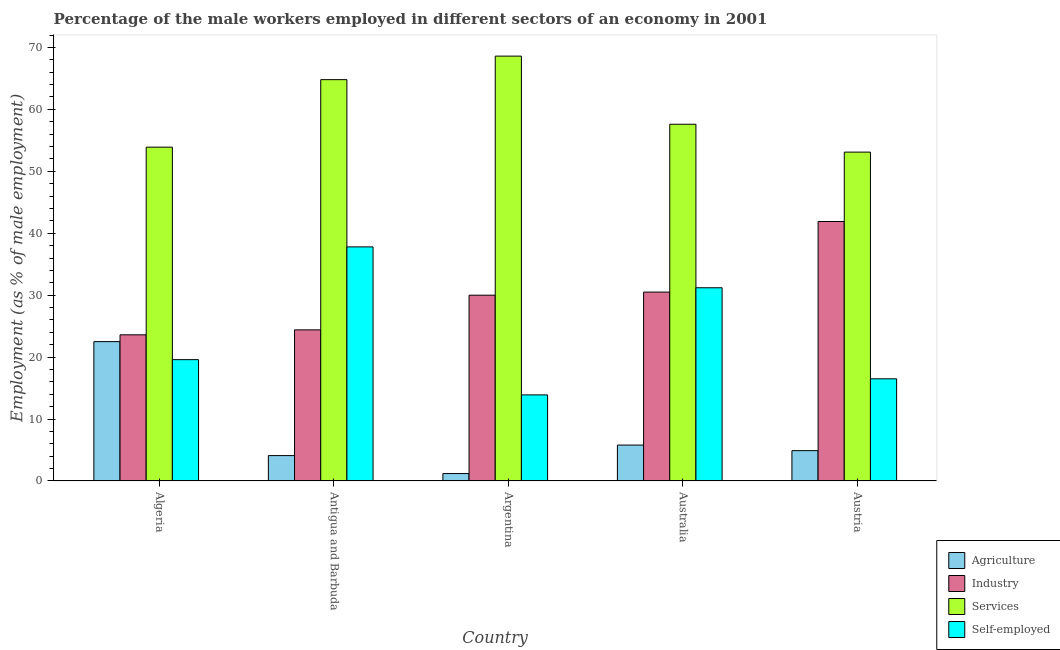How many different coloured bars are there?
Provide a short and direct response. 4. Are the number of bars per tick equal to the number of legend labels?
Provide a short and direct response. Yes. Are the number of bars on each tick of the X-axis equal?
Offer a very short reply. Yes. What is the label of the 2nd group of bars from the left?
Ensure brevity in your answer.  Antigua and Barbuda. What is the percentage of male workers in industry in Algeria?
Give a very brief answer. 23.6. Across all countries, what is the maximum percentage of male workers in industry?
Your answer should be compact. 41.9. Across all countries, what is the minimum percentage of self employed male workers?
Provide a succinct answer. 13.9. In which country was the percentage of self employed male workers maximum?
Give a very brief answer. Antigua and Barbuda. What is the total percentage of male workers in services in the graph?
Offer a terse response. 298. What is the difference between the percentage of male workers in industry in Australia and that in Austria?
Provide a succinct answer. -11.4. What is the difference between the percentage of self employed male workers in Australia and the percentage of male workers in industry in Algeria?
Keep it short and to the point. 7.6. What is the average percentage of male workers in services per country?
Ensure brevity in your answer.  59.6. What is the difference between the percentage of self employed male workers and percentage of male workers in agriculture in Australia?
Offer a terse response. 25.4. What is the ratio of the percentage of male workers in services in Algeria to that in Antigua and Barbuda?
Ensure brevity in your answer.  0.83. Is the difference between the percentage of male workers in industry in Algeria and Austria greater than the difference between the percentage of self employed male workers in Algeria and Austria?
Offer a very short reply. No. What is the difference between the highest and the second highest percentage of male workers in agriculture?
Provide a succinct answer. 16.7. What is the difference between the highest and the lowest percentage of self employed male workers?
Your answer should be very brief. 23.9. In how many countries, is the percentage of self employed male workers greater than the average percentage of self employed male workers taken over all countries?
Your response must be concise. 2. Is the sum of the percentage of male workers in services in Antigua and Barbuda and Australia greater than the maximum percentage of male workers in industry across all countries?
Your response must be concise. Yes. Is it the case that in every country, the sum of the percentage of male workers in services and percentage of male workers in agriculture is greater than the sum of percentage of self employed male workers and percentage of male workers in industry?
Ensure brevity in your answer.  Yes. What does the 1st bar from the left in Antigua and Barbuda represents?
Offer a very short reply. Agriculture. What does the 3rd bar from the right in Antigua and Barbuda represents?
Your answer should be compact. Industry. Are all the bars in the graph horizontal?
Ensure brevity in your answer.  No. What is the difference between two consecutive major ticks on the Y-axis?
Your answer should be very brief. 10. Does the graph contain any zero values?
Give a very brief answer. No. Does the graph contain grids?
Provide a short and direct response. No. Where does the legend appear in the graph?
Keep it short and to the point. Bottom right. How many legend labels are there?
Your response must be concise. 4. What is the title of the graph?
Your answer should be very brief. Percentage of the male workers employed in different sectors of an economy in 2001. What is the label or title of the X-axis?
Ensure brevity in your answer.  Country. What is the label or title of the Y-axis?
Provide a succinct answer. Employment (as % of male employment). What is the Employment (as % of male employment) of Industry in Algeria?
Provide a succinct answer. 23.6. What is the Employment (as % of male employment) in Services in Algeria?
Your response must be concise. 53.9. What is the Employment (as % of male employment) in Self-employed in Algeria?
Make the answer very short. 19.59. What is the Employment (as % of male employment) of Agriculture in Antigua and Barbuda?
Keep it short and to the point. 4.1. What is the Employment (as % of male employment) of Industry in Antigua and Barbuda?
Your answer should be very brief. 24.4. What is the Employment (as % of male employment) of Services in Antigua and Barbuda?
Offer a terse response. 64.8. What is the Employment (as % of male employment) of Self-employed in Antigua and Barbuda?
Give a very brief answer. 37.8. What is the Employment (as % of male employment) of Agriculture in Argentina?
Give a very brief answer. 1.2. What is the Employment (as % of male employment) in Industry in Argentina?
Your answer should be compact. 30. What is the Employment (as % of male employment) of Services in Argentina?
Your response must be concise. 68.6. What is the Employment (as % of male employment) of Self-employed in Argentina?
Ensure brevity in your answer.  13.9. What is the Employment (as % of male employment) in Agriculture in Australia?
Offer a terse response. 5.8. What is the Employment (as % of male employment) in Industry in Australia?
Offer a terse response. 30.5. What is the Employment (as % of male employment) of Services in Australia?
Your response must be concise. 57.6. What is the Employment (as % of male employment) of Self-employed in Australia?
Give a very brief answer. 31.2. What is the Employment (as % of male employment) in Agriculture in Austria?
Give a very brief answer. 4.9. What is the Employment (as % of male employment) in Industry in Austria?
Make the answer very short. 41.9. What is the Employment (as % of male employment) of Services in Austria?
Provide a succinct answer. 53.1. What is the Employment (as % of male employment) in Self-employed in Austria?
Offer a terse response. 16.5. Across all countries, what is the maximum Employment (as % of male employment) in Agriculture?
Provide a short and direct response. 22.5. Across all countries, what is the maximum Employment (as % of male employment) of Industry?
Your answer should be very brief. 41.9. Across all countries, what is the maximum Employment (as % of male employment) of Services?
Offer a terse response. 68.6. Across all countries, what is the maximum Employment (as % of male employment) in Self-employed?
Give a very brief answer. 37.8. Across all countries, what is the minimum Employment (as % of male employment) in Agriculture?
Offer a terse response. 1.2. Across all countries, what is the minimum Employment (as % of male employment) in Industry?
Give a very brief answer. 23.6. Across all countries, what is the minimum Employment (as % of male employment) of Services?
Your response must be concise. 53.1. Across all countries, what is the minimum Employment (as % of male employment) in Self-employed?
Your answer should be compact. 13.9. What is the total Employment (as % of male employment) of Agriculture in the graph?
Provide a short and direct response. 38.5. What is the total Employment (as % of male employment) in Industry in the graph?
Make the answer very short. 150.4. What is the total Employment (as % of male employment) of Services in the graph?
Your response must be concise. 298. What is the total Employment (as % of male employment) of Self-employed in the graph?
Your response must be concise. 118.99. What is the difference between the Employment (as % of male employment) in Agriculture in Algeria and that in Antigua and Barbuda?
Make the answer very short. 18.4. What is the difference between the Employment (as % of male employment) of Self-employed in Algeria and that in Antigua and Barbuda?
Keep it short and to the point. -18.21. What is the difference between the Employment (as % of male employment) in Agriculture in Algeria and that in Argentina?
Give a very brief answer. 21.3. What is the difference between the Employment (as % of male employment) in Industry in Algeria and that in Argentina?
Your response must be concise. -6.4. What is the difference between the Employment (as % of male employment) of Services in Algeria and that in Argentina?
Provide a short and direct response. -14.7. What is the difference between the Employment (as % of male employment) of Self-employed in Algeria and that in Argentina?
Offer a terse response. 5.69. What is the difference between the Employment (as % of male employment) in Self-employed in Algeria and that in Australia?
Provide a succinct answer. -11.61. What is the difference between the Employment (as % of male employment) in Industry in Algeria and that in Austria?
Keep it short and to the point. -18.3. What is the difference between the Employment (as % of male employment) of Self-employed in Algeria and that in Austria?
Provide a succinct answer. 3.09. What is the difference between the Employment (as % of male employment) of Self-employed in Antigua and Barbuda and that in Argentina?
Offer a very short reply. 23.9. What is the difference between the Employment (as % of male employment) of Self-employed in Antigua and Barbuda and that in Australia?
Your answer should be very brief. 6.6. What is the difference between the Employment (as % of male employment) in Industry in Antigua and Barbuda and that in Austria?
Provide a short and direct response. -17.5. What is the difference between the Employment (as % of male employment) of Services in Antigua and Barbuda and that in Austria?
Your response must be concise. 11.7. What is the difference between the Employment (as % of male employment) in Self-employed in Antigua and Barbuda and that in Austria?
Keep it short and to the point. 21.3. What is the difference between the Employment (as % of male employment) in Agriculture in Argentina and that in Australia?
Provide a short and direct response. -4.6. What is the difference between the Employment (as % of male employment) in Services in Argentina and that in Australia?
Ensure brevity in your answer.  11. What is the difference between the Employment (as % of male employment) in Self-employed in Argentina and that in Australia?
Your response must be concise. -17.3. What is the difference between the Employment (as % of male employment) of Services in Argentina and that in Austria?
Give a very brief answer. 15.5. What is the difference between the Employment (as % of male employment) in Self-employed in Argentina and that in Austria?
Provide a short and direct response. -2.6. What is the difference between the Employment (as % of male employment) in Agriculture in Australia and that in Austria?
Provide a short and direct response. 0.9. What is the difference between the Employment (as % of male employment) in Industry in Australia and that in Austria?
Give a very brief answer. -11.4. What is the difference between the Employment (as % of male employment) in Services in Australia and that in Austria?
Offer a very short reply. 4.5. What is the difference between the Employment (as % of male employment) of Self-employed in Australia and that in Austria?
Offer a terse response. 14.7. What is the difference between the Employment (as % of male employment) in Agriculture in Algeria and the Employment (as % of male employment) in Industry in Antigua and Barbuda?
Your answer should be very brief. -1.9. What is the difference between the Employment (as % of male employment) in Agriculture in Algeria and the Employment (as % of male employment) in Services in Antigua and Barbuda?
Offer a very short reply. -42.3. What is the difference between the Employment (as % of male employment) in Agriculture in Algeria and the Employment (as % of male employment) in Self-employed in Antigua and Barbuda?
Provide a short and direct response. -15.3. What is the difference between the Employment (as % of male employment) in Industry in Algeria and the Employment (as % of male employment) in Services in Antigua and Barbuda?
Offer a terse response. -41.2. What is the difference between the Employment (as % of male employment) of Services in Algeria and the Employment (as % of male employment) of Self-employed in Antigua and Barbuda?
Keep it short and to the point. 16.1. What is the difference between the Employment (as % of male employment) of Agriculture in Algeria and the Employment (as % of male employment) of Industry in Argentina?
Your response must be concise. -7.5. What is the difference between the Employment (as % of male employment) of Agriculture in Algeria and the Employment (as % of male employment) of Services in Argentina?
Make the answer very short. -46.1. What is the difference between the Employment (as % of male employment) of Industry in Algeria and the Employment (as % of male employment) of Services in Argentina?
Ensure brevity in your answer.  -45. What is the difference between the Employment (as % of male employment) of Agriculture in Algeria and the Employment (as % of male employment) of Industry in Australia?
Keep it short and to the point. -8. What is the difference between the Employment (as % of male employment) in Agriculture in Algeria and the Employment (as % of male employment) in Services in Australia?
Your answer should be compact. -35.1. What is the difference between the Employment (as % of male employment) of Industry in Algeria and the Employment (as % of male employment) of Services in Australia?
Offer a terse response. -34. What is the difference between the Employment (as % of male employment) of Industry in Algeria and the Employment (as % of male employment) of Self-employed in Australia?
Your response must be concise. -7.6. What is the difference between the Employment (as % of male employment) in Services in Algeria and the Employment (as % of male employment) in Self-employed in Australia?
Your response must be concise. 22.7. What is the difference between the Employment (as % of male employment) in Agriculture in Algeria and the Employment (as % of male employment) in Industry in Austria?
Your answer should be very brief. -19.4. What is the difference between the Employment (as % of male employment) in Agriculture in Algeria and the Employment (as % of male employment) in Services in Austria?
Offer a terse response. -30.6. What is the difference between the Employment (as % of male employment) of Industry in Algeria and the Employment (as % of male employment) of Services in Austria?
Provide a succinct answer. -29.5. What is the difference between the Employment (as % of male employment) in Services in Algeria and the Employment (as % of male employment) in Self-employed in Austria?
Offer a terse response. 37.4. What is the difference between the Employment (as % of male employment) in Agriculture in Antigua and Barbuda and the Employment (as % of male employment) in Industry in Argentina?
Ensure brevity in your answer.  -25.9. What is the difference between the Employment (as % of male employment) in Agriculture in Antigua and Barbuda and the Employment (as % of male employment) in Services in Argentina?
Your answer should be compact. -64.5. What is the difference between the Employment (as % of male employment) of Agriculture in Antigua and Barbuda and the Employment (as % of male employment) of Self-employed in Argentina?
Ensure brevity in your answer.  -9.8. What is the difference between the Employment (as % of male employment) in Industry in Antigua and Barbuda and the Employment (as % of male employment) in Services in Argentina?
Provide a succinct answer. -44.2. What is the difference between the Employment (as % of male employment) of Services in Antigua and Barbuda and the Employment (as % of male employment) of Self-employed in Argentina?
Ensure brevity in your answer.  50.9. What is the difference between the Employment (as % of male employment) in Agriculture in Antigua and Barbuda and the Employment (as % of male employment) in Industry in Australia?
Keep it short and to the point. -26.4. What is the difference between the Employment (as % of male employment) of Agriculture in Antigua and Barbuda and the Employment (as % of male employment) of Services in Australia?
Provide a succinct answer. -53.5. What is the difference between the Employment (as % of male employment) in Agriculture in Antigua and Barbuda and the Employment (as % of male employment) in Self-employed in Australia?
Give a very brief answer. -27.1. What is the difference between the Employment (as % of male employment) of Industry in Antigua and Barbuda and the Employment (as % of male employment) of Services in Australia?
Give a very brief answer. -33.2. What is the difference between the Employment (as % of male employment) of Services in Antigua and Barbuda and the Employment (as % of male employment) of Self-employed in Australia?
Ensure brevity in your answer.  33.6. What is the difference between the Employment (as % of male employment) in Agriculture in Antigua and Barbuda and the Employment (as % of male employment) in Industry in Austria?
Provide a succinct answer. -37.8. What is the difference between the Employment (as % of male employment) of Agriculture in Antigua and Barbuda and the Employment (as % of male employment) of Services in Austria?
Offer a terse response. -49. What is the difference between the Employment (as % of male employment) in Agriculture in Antigua and Barbuda and the Employment (as % of male employment) in Self-employed in Austria?
Offer a terse response. -12.4. What is the difference between the Employment (as % of male employment) of Industry in Antigua and Barbuda and the Employment (as % of male employment) of Services in Austria?
Your answer should be very brief. -28.7. What is the difference between the Employment (as % of male employment) in Services in Antigua and Barbuda and the Employment (as % of male employment) in Self-employed in Austria?
Ensure brevity in your answer.  48.3. What is the difference between the Employment (as % of male employment) in Agriculture in Argentina and the Employment (as % of male employment) in Industry in Australia?
Keep it short and to the point. -29.3. What is the difference between the Employment (as % of male employment) in Agriculture in Argentina and the Employment (as % of male employment) in Services in Australia?
Provide a succinct answer. -56.4. What is the difference between the Employment (as % of male employment) of Industry in Argentina and the Employment (as % of male employment) of Services in Australia?
Make the answer very short. -27.6. What is the difference between the Employment (as % of male employment) in Industry in Argentina and the Employment (as % of male employment) in Self-employed in Australia?
Offer a very short reply. -1.2. What is the difference between the Employment (as % of male employment) of Services in Argentina and the Employment (as % of male employment) of Self-employed in Australia?
Offer a very short reply. 37.4. What is the difference between the Employment (as % of male employment) in Agriculture in Argentina and the Employment (as % of male employment) in Industry in Austria?
Your response must be concise. -40.7. What is the difference between the Employment (as % of male employment) in Agriculture in Argentina and the Employment (as % of male employment) in Services in Austria?
Make the answer very short. -51.9. What is the difference between the Employment (as % of male employment) in Agriculture in Argentina and the Employment (as % of male employment) in Self-employed in Austria?
Make the answer very short. -15.3. What is the difference between the Employment (as % of male employment) of Industry in Argentina and the Employment (as % of male employment) of Services in Austria?
Make the answer very short. -23.1. What is the difference between the Employment (as % of male employment) in Services in Argentina and the Employment (as % of male employment) in Self-employed in Austria?
Offer a terse response. 52.1. What is the difference between the Employment (as % of male employment) of Agriculture in Australia and the Employment (as % of male employment) of Industry in Austria?
Your response must be concise. -36.1. What is the difference between the Employment (as % of male employment) in Agriculture in Australia and the Employment (as % of male employment) in Services in Austria?
Your answer should be compact. -47.3. What is the difference between the Employment (as % of male employment) in Agriculture in Australia and the Employment (as % of male employment) in Self-employed in Austria?
Your response must be concise. -10.7. What is the difference between the Employment (as % of male employment) of Industry in Australia and the Employment (as % of male employment) of Services in Austria?
Ensure brevity in your answer.  -22.6. What is the difference between the Employment (as % of male employment) of Services in Australia and the Employment (as % of male employment) of Self-employed in Austria?
Keep it short and to the point. 41.1. What is the average Employment (as % of male employment) in Agriculture per country?
Offer a very short reply. 7.7. What is the average Employment (as % of male employment) in Industry per country?
Provide a succinct answer. 30.08. What is the average Employment (as % of male employment) of Services per country?
Offer a terse response. 59.6. What is the average Employment (as % of male employment) in Self-employed per country?
Your answer should be compact. 23.8. What is the difference between the Employment (as % of male employment) in Agriculture and Employment (as % of male employment) in Services in Algeria?
Your answer should be compact. -31.4. What is the difference between the Employment (as % of male employment) in Agriculture and Employment (as % of male employment) in Self-employed in Algeria?
Offer a very short reply. 2.91. What is the difference between the Employment (as % of male employment) in Industry and Employment (as % of male employment) in Services in Algeria?
Offer a terse response. -30.3. What is the difference between the Employment (as % of male employment) of Industry and Employment (as % of male employment) of Self-employed in Algeria?
Give a very brief answer. 4.01. What is the difference between the Employment (as % of male employment) of Services and Employment (as % of male employment) of Self-employed in Algeria?
Offer a very short reply. 34.31. What is the difference between the Employment (as % of male employment) in Agriculture and Employment (as % of male employment) in Industry in Antigua and Barbuda?
Make the answer very short. -20.3. What is the difference between the Employment (as % of male employment) in Agriculture and Employment (as % of male employment) in Services in Antigua and Barbuda?
Offer a very short reply. -60.7. What is the difference between the Employment (as % of male employment) in Agriculture and Employment (as % of male employment) in Self-employed in Antigua and Barbuda?
Offer a very short reply. -33.7. What is the difference between the Employment (as % of male employment) of Industry and Employment (as % of male employment) of Services in Antigua and Barbuda?
Offer a terse response. -40.4. What is the difference between the Employment (as % of male employment) of Agriculture and Employment (as % of male employment) of Industry in Argentina?
Provide a short and direct response. -28.8. What is the difference between the Employment (as % of male employment) in Agriculture and Employment (as % of male employment) in Services in Argentina?
Provide a succinct answer. -67.4. What is the difference between the Employment (as % of male employment) in Industry and Employment (as % of male employment) in Services in Argentina?
Keep it short and to the point. -38.6. What is the difference between the Employment (as % of male employment) of Services and Employment (as % of male employment) of Self-employed in Argentina?
Your response must be concise. 54.7. What is the difference between the Employment (as % of male employment) of Agriculture and Employment (as % of male employment) of Industry in Australia?
Make the answer very short. -24.7. What is the difference between the Employment (as % of male employment) in Agriculture and Employment (as % of male employment) in Services in Australia?
Provide a short and direct response. -51.8. What is the difference between the Employment (as % of male employment) of Agriculture and Employment (as % of male employment) of Self-employed in Australia?
Your response must be concise. -25.4. What is the difference between the Employment (as % of male employment) in Industry and Employment (as % of male employment) in Services in Australia?
Your answer should be very brief. -27.1. What is the difference between the Employment (as % of male employment) in Services and Employment (as % of male employment) in Self-employed in Australia?
Give a very brief answer. 26.4. What is the difference between the Employment (as % of male employment) in Agriculture and Employment (as % of male employment) in Industry in Austria?
Give a very brief answer. -37. What is the difference between the Employment (as % of male employment) in Agriculture and Employment (as % of male employment) in Services in Austria?
Ensure brevity in your answer.  -48.2. What is the difference between the Employment (as % of male employment) in Industry and Employment (as % of male employment) in Services in Austria?
Keep it short and to the point. -11.2. What is the difference between the Employment (as % of male employment) of Industry and Employment (as % of male employment) of Self-employed in Austria?
Ensure brevity in your answer.  25.4. What is the difference between the Employment (as % of male employment) in Services and Employment (as % of male employment) in Self-employed in Austria?
Make the answer very short. 36.6. What is the ratio of the Employment (as % of male employment) in Agriculture in Algeria to that in Antigua and Barbuda?
Keep it short and to the point. 5.49. What is the ratio of the Employment (as % of male employment) in Industry in Algeria to that in Antigua and Barbuda?
Give a very brief answer. 0.97. What is the ratio of the Employment (as % of male employment) of Services in Algeria to that in Antigua and Barbuda?
Provide a short and direct response. 0.83. What is the ratio of the Employment (as % of male employment) in Self-employed in Algeria to that in Antigua and Barbuda?
Your answer should be compact. 0.52. What is the ratio of the Employment (as % of male employment) in Agriculture in Algeria to that in Argentina?
Ensure brevity in your answer.  18.75. What is the ratio of the Employment (as % of male employment) in Industry in Algeria to that in Argentina?
Your answer should be compact. 0.79. What is the ratio of the Employment (as % of male employment) of Services in Algeria to that in Argentina?
Make the answer very short. 0.79. What is the ratio of the Employment (as % of male employment) in Self-employed in Algeria to that in Argentina?
Your answer should be very brief. 1.41. What is the ratio of the Employment (as % of male employment) of Agriculture in Algeria to that in Australia?
Provide a short and direct response. 3.88. What is the ratio of the Employment (as % of male employment) of Industry in Algeria to that in Australia?
Offer a terse response. 0.77. What is the ratio of the Employment (as % of male employment) in Services in Algeria to that in Australia?
Offer a terse response. 0.94. What is the ratio of the Employment (as % of male employment) of Self-employed in Algeria to that in Australia?
Your answer should be compact. 0.63. What is the ratio of the Employment (as % of male employment) of Agriculture in Algeria to that in Austria?
Give a very brief answer. 4.59. What is the ratio of the Employment (as % of male employment) of Industry in Algeria to that in Austria?
Offer a very short reply. 0.56. What is the ratio of the Employment (as % of male employment) in Services in Algeria to that in Austria?
Make the answer very short. 1.02. What is the ratio of the Employment (as % of male employment) of Self-employed in Algeria to that in Austria?
Give a very brief answer. 1.19. What is the ratio of the Employment (as % of male employment) in Agriculture in Antigua and Barbuda to that in Argentina?
Your answer should be compact. 3.42. What is the ratio of the Employment (as % of male employment) in Industry in Antigua and Barbuda to that in Argentina?
Ensure brevity in your answer.  0.81. What is the ratio of the Employment (as % of male employment) of Services in Antigua and Barbuda to that in Argentina?
Provide a succinct answer. 0.94. What is the ratio of the Employment (as % of male employment) in Self-employed in Antigua and Barbuda to that in Argentina?
Make the answer very short. 2.72. What is the ratio of the Employment (as % of male employment) of Agriculture in Antigua and Barbuda to that in Australia?
Provide a succinct answer. 0.71. What is the ratio of the Employment (as % of male employment) in Industry in Antigua and Barbuda to that in Australia?
Offer a terse response. 0.8. What is the ratio of the Employment (as % of male employment) in Self-employed in Antigua and Barbuda to that in Australia?
Offer a terse response. 1.21. What is the ratio of the Employment (as % of male employment) of Agriculture in Antigua and Barbuda to that in Austria?
Your answer should be very brief. 0.84. What is the ratio of the Employment (as % of male employment) in Industry in Antigua and Barbuda to that in Austria?
Make the answer very short. 0.58. What is the ratio of the Employment (as % of male employment) in Services in Antigua and Barbuda to that in Austria?
Your answer should be very brief. 1.22. What is the ratio of the Employment (as % of male employment) in Self-employed in Antigua and Barbuda to that in Austria?
Your answer should be compact. 2.29. What is the ratio of the Employment (as % of male employment) of Agriculture in Argentina to that in Australia?
Keep it short and to the point. 0.21. What is the ratio of the Employment (as % of male employment) in Industry in Argentina to that in Australia?
Your answer should be very brief. 0.98. What is the ratio of the Employment (as % of male employment) of Services in Argentina to that in Australia?
Give a very brief answer. 1.19. What is the ratio of the Employment (as % of male employment) in Self-employed in Argentina to that in Australia?
Keep it short and to the point. 0.45. What is the ratio of the Employment (as % of male employment) in Agriculture in Argentina to that in Austria?
Your answer should be very brief. 0.24. What is the ratio of the Employment (as % of male employment) in Industry in Argentina to that in Austria?
Provide a succinct answer. 0.72. What is the ratio of the Employment (as % of male employment) in Services in Argentina to that in Austria?
Your answer should be very brief. 1.29. What is the ratio of the Employment (as % of male employment) of Self-employed in Argentina to that in Austria?
Your answer should be compact. 0.84. What is the ratio of the Employment (as % of male employment) in Agriculture in Australia to that in Austria?
Keep it short and to the point. 1.18. What is the ratio of the Employment (as % of male employment) of Industry in Australia to that in Austria?
Provide a succinct answer. 0.73. What is the ratio of the Employment (as % of male employment) in Services in Australia to that in Austria?
Provide a short and direct response. 1.08. What is the ratio of the Employment (as % of male employment) in Self-employed in Australia to that in Austria?
Make the answer very short. 1.89. What is the difference between the highest and the second highest Employment (as % of male employment) of Agriculture?
Keep it short and to the point. 16.7. What is the difference between the highest and the lowest Employment (as % of male employment) of Agriculture?
Keep it short and to the point. 21.3. What is the difference between the highest and the lowest Employment (as % of male employment) in Industry?
Your answer should be very brief. 18.3. What is the difference between the highest and the lowest Employment (as % of male employment) of Self-employed?
Offer a very short reply. 23.9. 